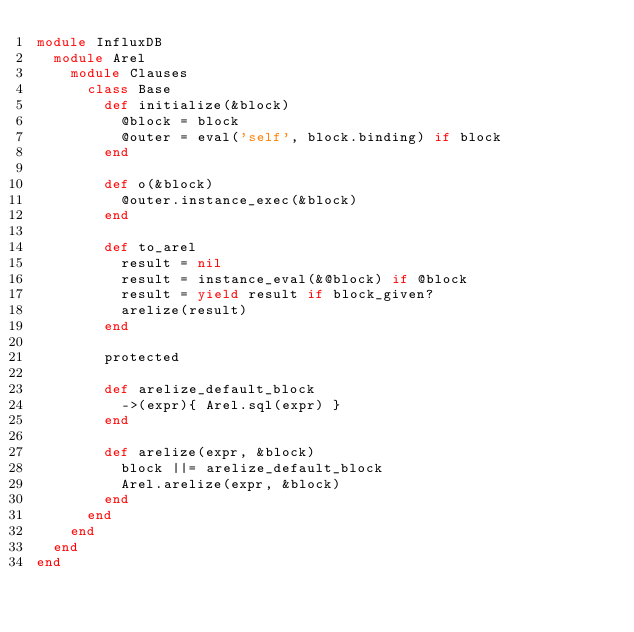<code> <loc_0><loc_0><loc_500><loc_500><_Ruby_>module InfluxDB
  module Arel
    module Clauses
      class Base
        def initialize(&block)
          @block = block
          @outer = eval('self', block.binding) if block
        end

        def o(&block)
          @outer.instance_exec(&block)
        end

        def to_arel
          result = nil
          result = instance_eval(&@block) if @block
          result = yield result if block_given?
          arelize(result)
        end

        protected

        def arelize_default_block
          ->(expr){ Arel.sql(expr) }
        end

        def arelize(expr, &block)
          block ||= arelize_default_block
          Arel.arelize(expr, &block)
        end
      end
    end
  end
end
</code> 